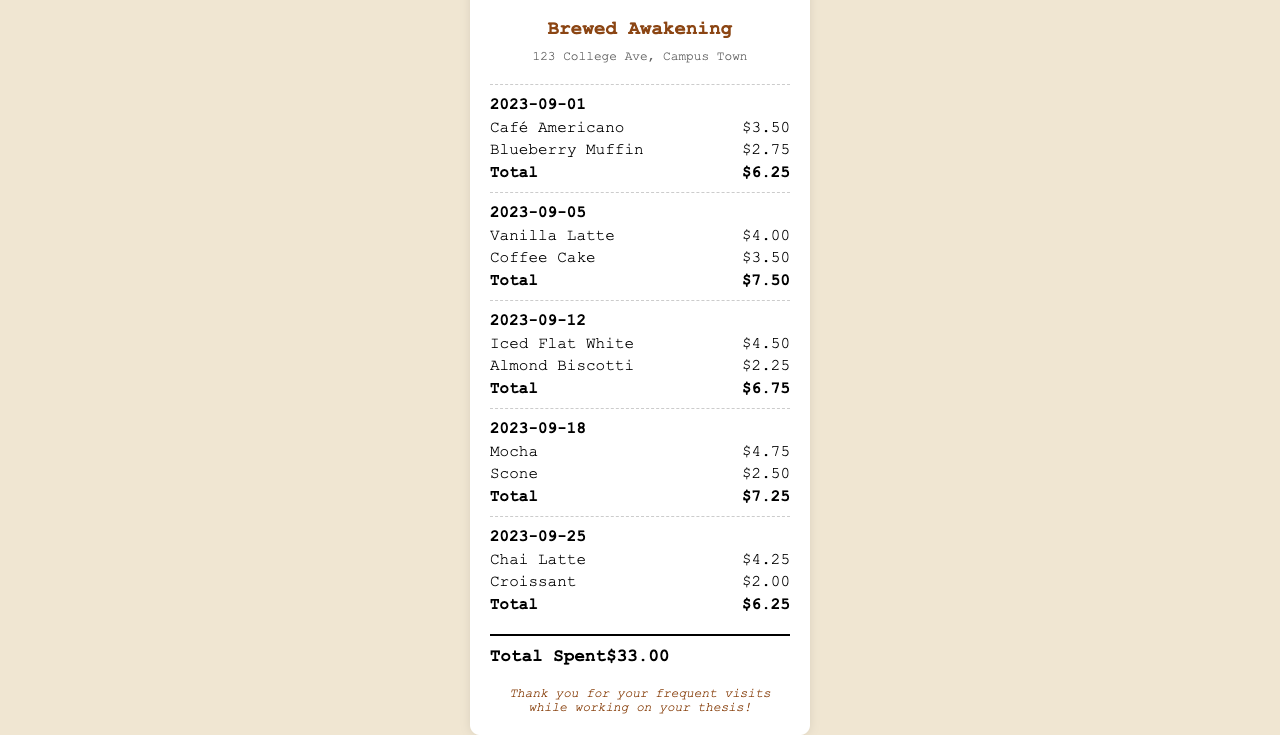What is the name of the coffee shop? The name of the coffee shop is displayed at the top of the receipt.
Answer: Brewed Awakening What is the address of the coffee shop? The address is mentioned below the name of the coffee shop.
Answer: 123 College Ave, Campus Town What was purchased on September 5, 2023? The items bought on that date are listed under the visit section for that date.
Answer: Vanilla Latte, Coffee Cake What is the total amount spent on September 18, 2023? The total is provided at the end of the itemized purchases for that visit.
Answer: $7.25 How much was spent in total? The grand total is shown at the bottom of the receipt, summing up all visits.
Answer: $33.00 What type of item was purchased on September 12, 2023? The types of items purchased can be found in the itemized list for that date.
Answer: Iced Flat White, Almond Biscotti How many visits are documented? The visits are listed sequentially, and counting them provides the total.
Answer: 5 What is the date of the first purchase? The date of the first visit is shown at the top of the visit section.
Answer: 2023-09-01 What dessert was purchased alongside the Mocha? The dessert is listed in the same section as the beverage.
Answer: Scone 